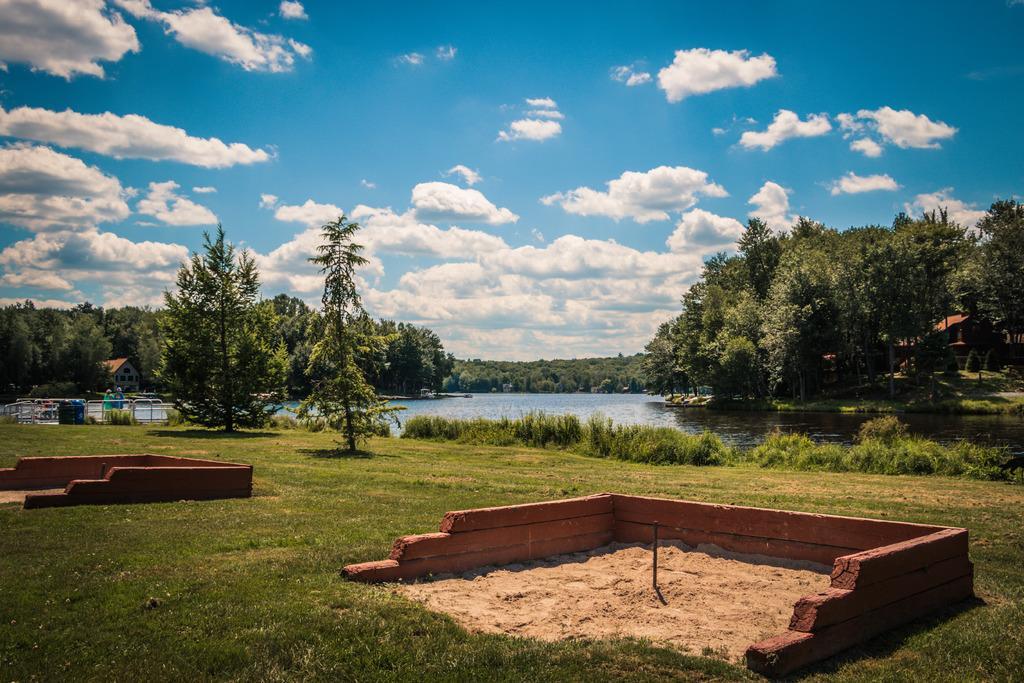Describe this image in one or two sentences. In this picture I can observe a lake in the middle of the picture. I can observe some grass on the ground. In the background there are trees and some clouds in the sky. 